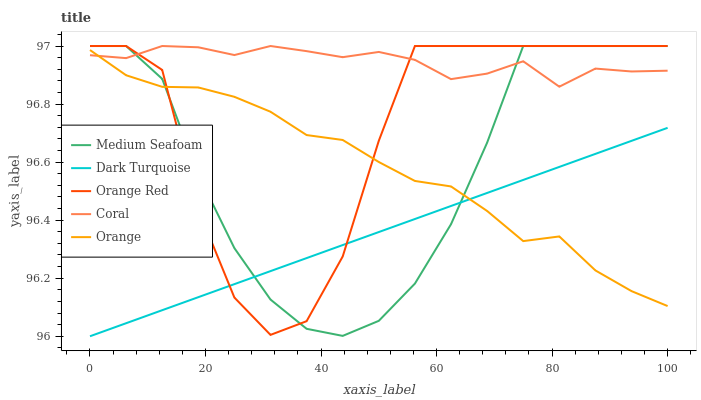Does Dark Turquoise have the minimum area under the curve?
Answer yes or no. Yes. Does Coral have the minimum area under the curve?
Answer yes or no. No. Does Dark Turquoise have the maximum area under the curve?
Answer yes or no. No. Is Coral the smoothest?
Answer yes or no. No. Is Coral the roughest?
Answer yes or no. No. Does Coral have the lowest value?
Answer yes or no. No. Does Dark Turquoise have the highest value?
Answer yes or no. No. Is Dark Turquoise less than Coral?
Answer yes or no. Yes. Is Coral greater than Dark Turquoise?
Answer yes or no. Yes. Does Dark Turquoise intersect Coral?
Answer yes or no. No. 